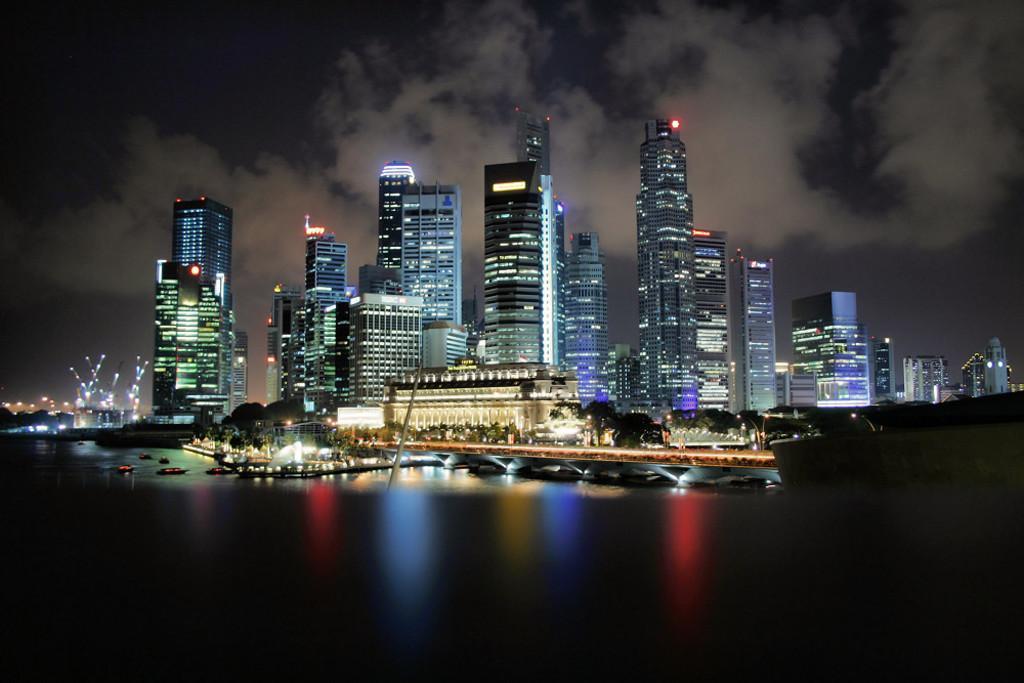How would you summarize this image in a sentence or two? The image is taken in the nighttime. In this image there are so many tall buildings in the middle. In front of them there is water on which there are boats. In the water there is a bridge. At the top there is sky. There are lights all over the place. 